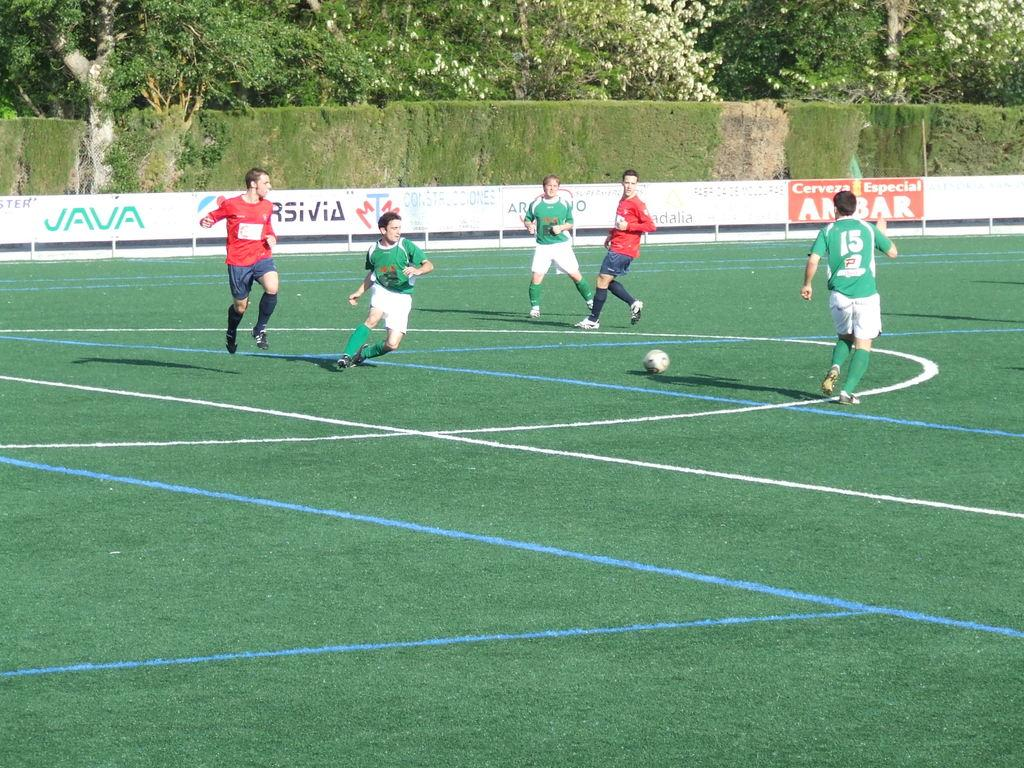<image>
Share a concise interpretation of the image provided. A group of people playing soccer with a JAVA advertisement behind them. 